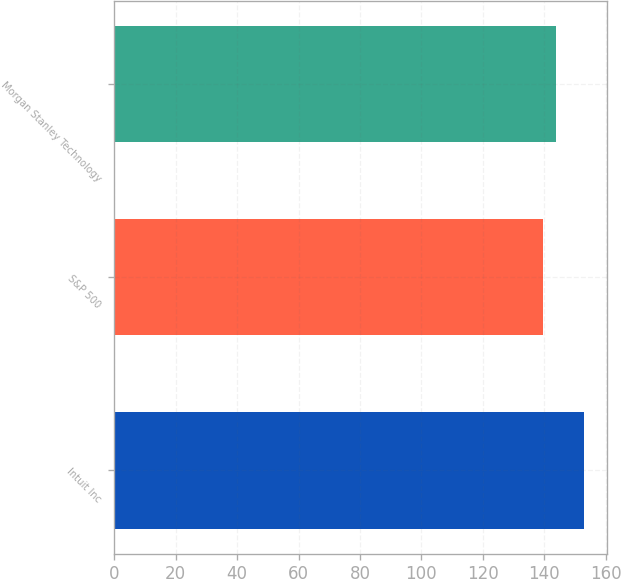<chart> <loc_0><loc_0><loc_500><loc_500><bar_chart><fcel>Intuit Inc<fcel>S&P 500<fcel>Morgan Stanley Technology<nl><fcel>152.99<fcel>139.58<fcel>144.03<nl></chart> 